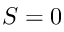Convert formula to latex. <formula><loc_0><loc_0><loc_500><loc_500>S = 0</formula> 